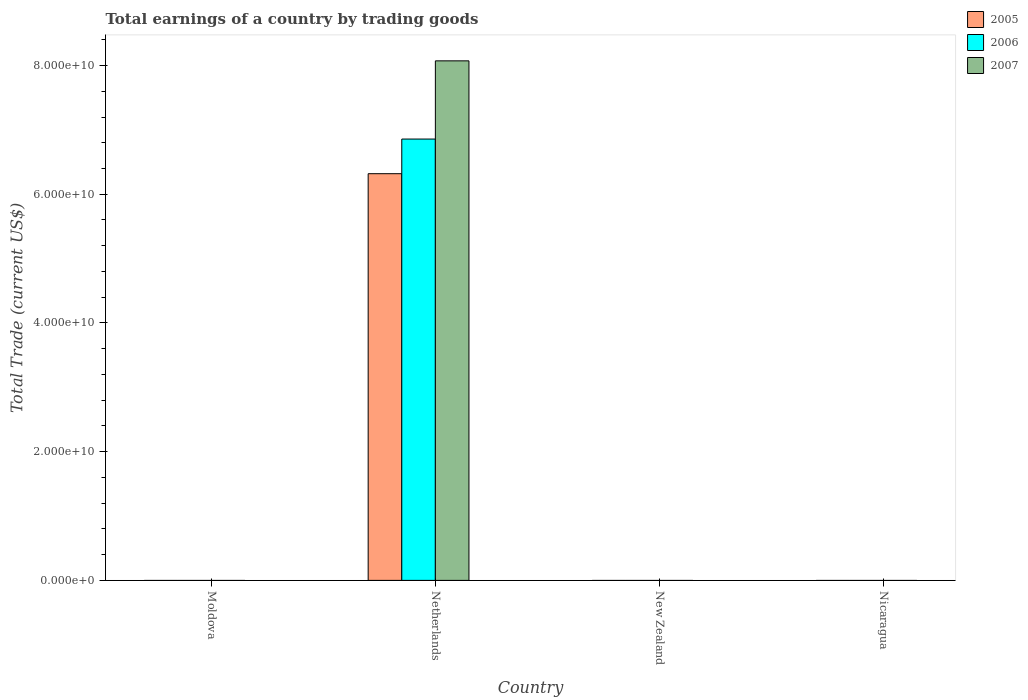Are the number of bars on each tick of the X-axis equal?
Your answer should be compact. No. How many bars are there on the 2nd tick from the right?
Provide a short and direct response. 0. What is the label of the 2nd group of bars from the left?
Give a very brief answer. Netherlands. In how many cases, is the number of bars for a given country not equal to the number of legend labels?
Offer a very short reply. 3. Across all countries, what is the maximum total earnings in 2007?
Offer a terse response. 8.07e+1. What is the total total earnings in 2006 in the graph?
Offer a terse response. 6.86e+1. What is the difference between the total earnings in 2007 in Netherlands and the total earnings in 2006 in New Zealand?
Offer a terse response. 8.07e+1. What is the average total earnings in 2007 per country?
Provide a succinct answer. 2.02e+1. What is the difference between the total earnings of/in 2007 and total earnings of/in 2005 in Netherlands?
Your answer should be compact. 1.75e+1. What is the difference between the highest and the lowest total earnings in 2006?
Offer a terse response. 6.86e+1. Is it the case that in every country, the sum of the total earnings in 2006 and total earnings in 2007 is greater than the total earnings in 2005?
Make the answer very short. No. How many bars are there?
Your response must be concise. 3. Are all the bars in the graph horizontal?
Ensure brevity in your answer.  No. How many countries are there in the graph?
Your response must be concise. 4. What is the difference between two consecutive major ticks on the Y-axis?
Provide a succinct answer. 2.00e+1. Does the graph contain any zero values?
Give a very brief answer. Yes. How many legend labels are there?
Give a very brief answer. 3. What is the title of the graph?
Give a very brief answer. Total earnings of a country by trading goods. Does "1978" appear as one of the legend labels in the graph?
Make the answer very short. No. What is the label or title of the X-axis?
Give a very brief answer. Country. What is the label or title of the Y-axis?
Your answer should be very brief. Total Trade (current US$). What is the Total Trade (current US$) of 2005 in Moldova?
Your response must be concise. 0. What is the Total Trade (current US$) of 2007 in Moldova?
Offer a very short reply. 0. What is the Total Trade (current US$) of 2005 in Netherlands?
Offer a terse response. 6.32e+1. What is the Total Trade (current US$) of 2006 in Netherlands?
Your answer should be compact. 6.86e+1. What is the Total Trade (current US$) in 2007 in Netherlands?
Offer a terse response. 8.07e+1. What is the Total Trade (current US$) of 2006 in New Zealand?
Provide a short and direct response. 0. What is the Total Trade (current US$) of 2005 in Nicaragua?
Provide a short and direct response. 0. What is the Total Trade (current US$) in 2006 in Nicaragua?
Ensure brevity in your answer.  0. What is the Total Trade (current US$) in 2007 in Nicaragua?
Offer a terse response. 0. Across all countries, what is the maximum Total Trade (current US$) of 2005?
Ensure brevity in your answer.  6.32e+1. Across all countries, what is the maximum Total Trade (current US$) of 2006?
Provide a succinct answer. 6.86e+1. Across all countries, what is the maximum Total Trade (current US$) of 2007?
Your answer should be compact. 8.07e+1. Across all countries, what is the minimum Total Trade (current US$) in 2007?
Ensure brevity in your answer.  0. What is the total Total Trade (current US$) of 2005 in the graph?
Offer a very short reply. 6.32e+1. What is the total Total Trade (current US$) in 2006 in the graph?
Keep it short and to the point. 6.86e+1. What is the total Total Trade (current US$) of 2007 in the graph?
Make the answer very short. 8.07e+1. What is the average Total Trade (current US$) of 2005 per country?
Provide a succinct answer. 1.58e+1. What is the average Total Trade (current US$) in 2006 per country?
Offer a terse response. 1.71e+1. What is the average Total Trade (current US$) of 2007 per country?
Keep it short and to the point. 2.02e+1. What is the difference between the Total Trade (current US$) in 2005 and Total Trade (current US$) in 2006 in Netherlands?
Provide a succinct answer. -5.38e+09. What is the difference between the Total Trade (current US$) in 2005 and Total Trade (current US$) in 2007 in Netherlands?
Give a very brief answer. -1.75e+1. What is the difference between the Total Trade (current US$) in 2006 and Total Trade (current US$) in 2007 in Netherlands?
Provide a short and direct response. -1.22e+1. What is the difference between the highest and the lowest Total Trade (current US$) in 2005?
Your answer should be compact. 6.32e+1. What is the difference between the highest and the lowest Total Trade (current US$) in 2006?
Offer a terse response. 6.86e+1. What is the difference between the highest and the lowest Total Trade (current US$) of 2007?
Ensure brevity in your answer.  8.07e+1. 